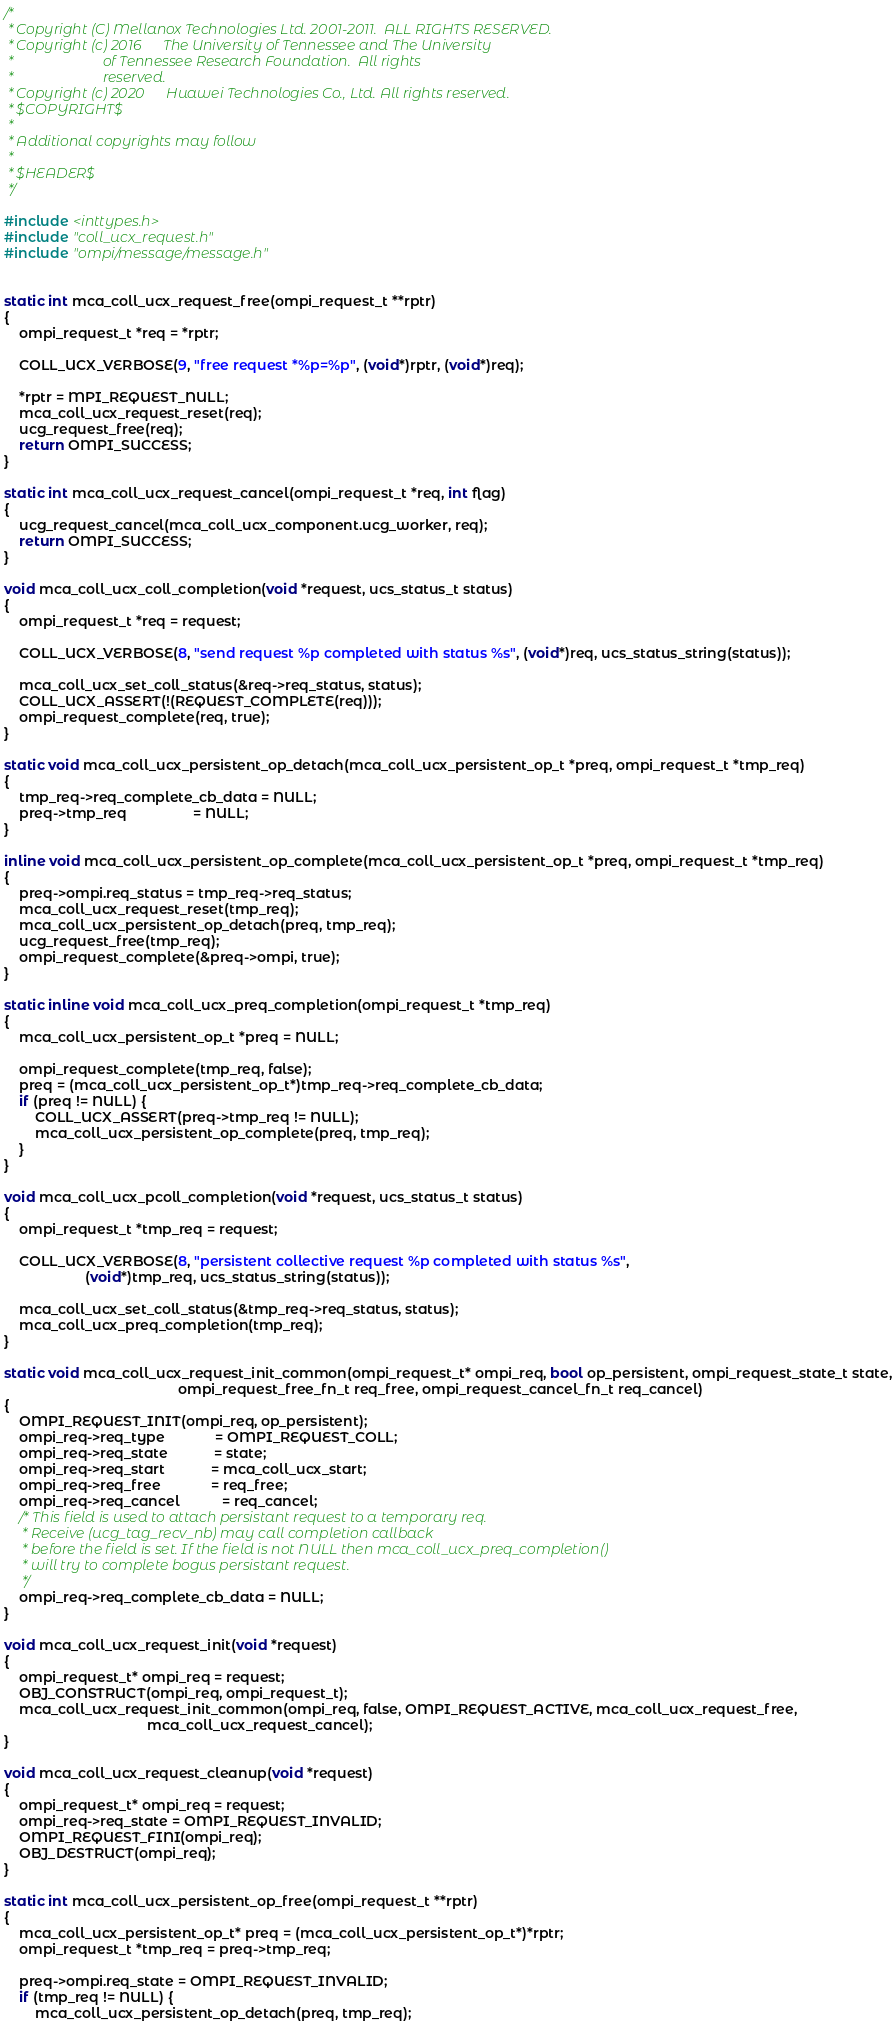<code> <loc_0><loc_0><loc_500><loc_500><_C_>/*
 * Copyright (C) Mellanox Technologies Ltd. 2001-2011.  ALL RIGHTS RESERVED.
 * Copyright (c) 2016      The University of Tennessee and The University
 *                         of Tennessee Research Foundation.  All rights
 *                         reserved.
 * Copyright (c) 2020      Huawei Technologies Co., Ltd. All rights reserved.
 * $COPYRIGHT$
 *
 * Additional copyrights may follow
 *
 * $HEADER$
 */

#include <inttypes.h>
#include "coll_ucx_request.h"
#include "ompi/message/message.h"


static int mca_coll_ucx_request_free(ompi_request_t **rptr)
{
    ompi_request_t *req = *rptr;

    COLL_UCX_VERBOSE(9, "free request *%p=%p", (void*)rptr, (void*)req);

    *rptr = MPI_REQUEST_NULL;
    mca_coll_ucx_request_reset(req);
    ucg_request_free(req);
    return OMPI_SUCCESS;
}

static int mca_coll_ucx_request_cancel(ompi_request_t *req, int flag)
{
    ucg_request_cancel(mca_coll_ucx_component.ucg_worker, req);
    return OMPI_SUCCESS;
}

void mca_coll_ucx_coll_completion(void *request, ucs_status_t status)
{
    ompi_request_t *req = request;

    COLL_UCX_VERBOSE(8, "send request %p completed with status %s", (void*)req, ucs_status_string(status));

    mca_coll_ucx_set_coll_status(&req->req_status, status);
    COLL_UCX_ASSERT(!(REQUEST_COMPLETE(req)));
    ompi_request_complete(req, true);
}

static void mca_coll_ucx_persistent_op_detach(mca_coll_ucx_persistent_op_t *preq, ompi_request_t *tmp_req)
{
    tmp_req->req_complete_cb_data = NULL;
    preq->tmp_req                 = NULL;
}

inline void mca_coll_ucx_persistent_op_complete(mca_coll_ucx_persistent_op_t *preq, ompi_request_t *tmp_req)
{
    preq->ompi.req_status = tmp_req->req_status;
    mca_coll_ucx_request_reset(tmp_req);
    mca_coll_ucx_persistent_op_detach(preq, tmp_req);
    ucg_request_free(tmp_req);
    ompi_request_complete(&preq->ompi, true);
}

static inline void mca_coll_ucx_preq_completion(ompi_request_t *tmp_req)
{
    mca_coll_ucx_persistent_op_t *preq = NULL;

    ompi_request_complete(tmp_req, false);
    preq = (mca_coll_ucx_persistent_op_t*)tmp_req->req_complete_cb_data;
    if (preq != NULL) {
        COLL_UCX_ASSERT(preq->tmp_req != NULL);
        mca_coll_ucx_persistent_op_complete(preq, tmp_req);
    }
}

void mca_coll_ucx_pcoll_completion(void *request, ucs_status_t status)
{
    ompi_request_t *tmp_req = request;

    COLL_UCX_VERBOSE(8, "persistent collective request %p completed with status %s",
                     (void*)tmp_req, ucs_status_string(status));

    mca_coll_ucx_set_coll_status(&tmp_req->req_status, status);
    mca_coll_ucx_preq_completion(tmp_req);
}

static void mca_coll_ucx_request_init_common(ompi_request_t* ompi_req, bool op_persistent, ompi_request_state_t state,
                                             ompi_request_free_fn_t req_free, ompi_request_cancel_fn_t req_cancel)
{
    OMPI_REQUEST_INIT(ompi_req, op_persistent);
    ompi_req->req_type             = OMPI_REQUEST_COLL;
    ompi_req->req_state            = state;
    ompi_req->req_start            = mca_coll_ucx_start;
    ompi_req->req_free             = req_free;
    ompi_req->req_cancel           = req_cancel;
    /* This field is used to attach persistant request to a temporary req.
     * Receive (ucg_tag_recv_nb) may call completion callback
     * before the field is set. If the field is not NULL then mca_coll_ucx_preq_completion()
     * will try to complete bogus persistant request.
     */
    ompi_req->req_complete_cb_data = NULL;
}

void mca_coll_ucx_request_init(void *request)
{
    ompi_request_t* ompi_req = request;
    OBJ_CONSTRUCT(ompi_req, ompi_request_t);
    mca_coll_ucx_request_init_common(ompi_req, false, OMPI_REQUEST_ACTIVE, mca_coll_ucx_request_free,
                                     mca_coll_ucx_request_cancel);
}

void mca_coll_ucx_request_cleanup(void *request)
{
    ompi_request_t* ompi_req = request;
    ompi_req->req_state = OMPI_REQUEST_INVALID;
    OMPI_REQUEST_FINI(ompi_req);
    OBJ_DESTRUCT(ompi_req);
}

static int mca_coll_ucx_persistent_op_free(ompi_request_t **rptr)
{
    mca_coll_ucx_persistent_op_t* preq = (mca_coll_ucx_persistent_op_t*)*rptr;
    ompi_request_t *tmp_req = preq->tmp_req;

    preq->ompi.req_state = OMPI_REQUEST_INVALID;
    if (tmp_req != NULL) {
        mca_coll_ucx_persistent_op_detach(preq, tmp_req);</code> 